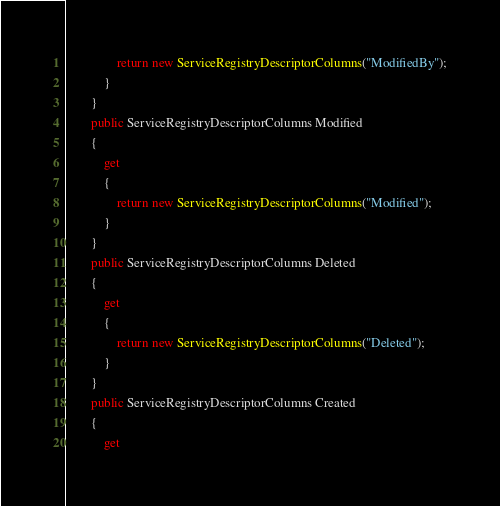Convert code to text. <code><loc_0><loc_0><loc_500><loc_500><_C#_>                return new ServiceRegistryDescriptorColumns("ModifiedBy");
            }
        }
        public ServiceRegistryDescriptorColumns Modified
        {
            get
            {
                return new ServiceRegistryDescriptorColumns("Modified");
            }
        }
        public ServiceRegistryDescriptorColumns Deleted
        {
            get
            {
                return new ServiceRegistryDescriptorColumns("Deleted");
            }
        }
        public ServiceRegistryDescriptorColumns Created
        {
            get</code> 